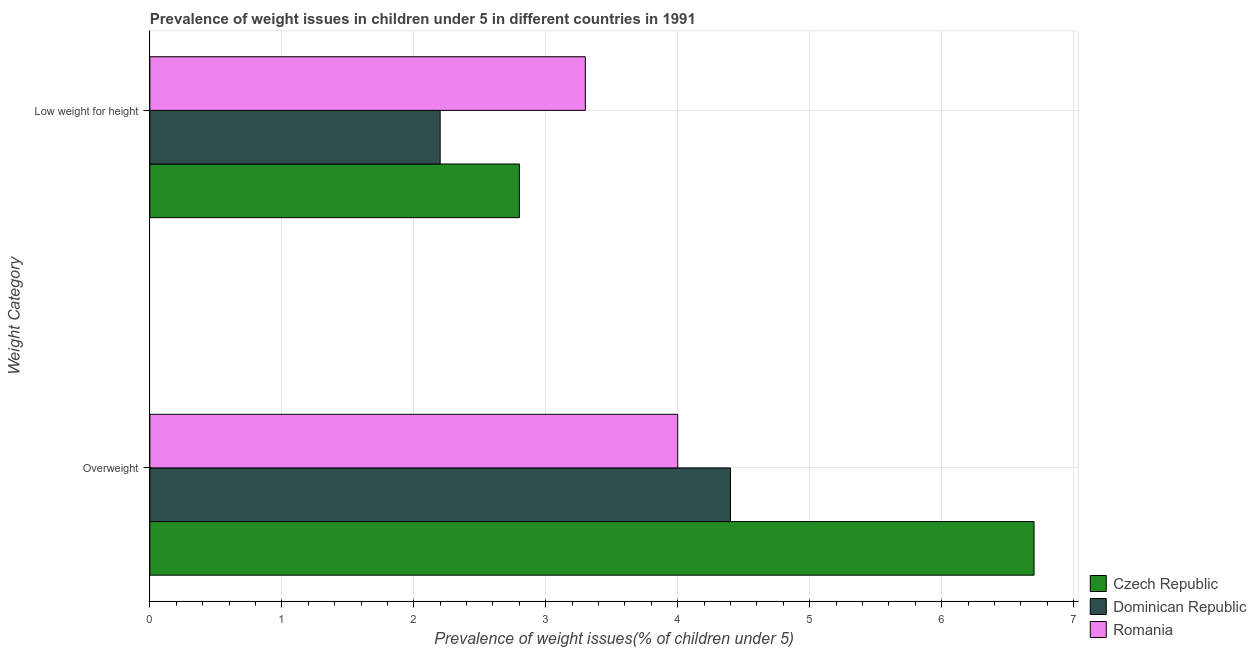How many different coloured bars are there?
Keep it short and to the point. 3. How many groups of bars are there?
Provide a succinct answer. 2. What is the label of the 1st group of bars from the top?
Make the answer very short. Low weight for height. What is the percentage of overweight children in Czech Republic?
Your response must be concise. 6.7. Across all countries, what is the maximum percentage of overweight children?
Offer a terse response. 6.7. Across all countries, what is the minimum percentage of overweight children?
Offer a terse response. 4. In which country was the percentage of underweight children maximum?
Your answer should be very brief. Romania. In which country was the percentage of underweight children minimum?
Your answer should be very brief. Dominican Republic. What is the total percentage of underweight children in the graph?
Offer a very short reply. 8.3. What is the difference between the percentage of overweight children in Czech Republic and that in Dominican Republic?
Make the answer very short. 2.3. What is the difference between the percentage of overweight children in Czech Republic and the percentage of underweight children in Romania?
Your response must be concise. 3.4. What is the average percentage of underweight children per country?
Provide a succinct answer. 2.77. What is the difference between the percentage of underweight children and percentage of overweight children in Dominican Republic?
Offer a terse response. -2.2. In how many countries, is the percentage of overweight children greater than 1.2 %?
Offer a terse response. 3. What is the ratio of the percentage of overweight children in Czech Republic to that in Romania?
Your response must be concise. 1.67. Is the percentage of overweight children in Dominican Republic less than that in Czech Republic?
Your answer should be compact. Yes. What does the 3rd bar from the top in Low weight for height represents?
Your answer should be very brief. Czech Republic. What does the 2nd bar from the bottom in Overweight represents?
Ensure brevity in your answer.  Dominican Republic. How many bars are there?
Keep it short and to the point. 6. What is the difference between two consecutive major ticks on the X-axis?
Make the answer very short. 1. Does the graph contain any zero values?
Provide a succinct answer. No. Does the graph contain grids?
Give a very brief answer. Yes. Where does the legend appear in the graph?
Provide a succinct answer. Bottom right. How many legend labels are there?
Your response must be concise. 3. What is the title of the graph?
Give a very brief answer. Prevalence of weight issues in children under 5 in different countries in 1991. Does "Small states" appear as one of the legend labels in the graph?
Your answer should be compact. No. What is the label or title of the X-axis?
Your response must be concise. Prevalence of weight issues(% of children under 5). What is the label or title of the Y-axis?
Give a very brief answer. Weight Category. What is the Prevalence of weight issues(% of children under 5) of Czech Republic in Overweight?
Your response must be concise. 6.7. What is the Prevalence of weight issues(% of children under 5) of Dominican Republic in Overweight?
Provide a succinct answer. 4.4. What is the Prevalence of weight issues(% of children under 5) in Romania in Overweight?
Offer a very short reply. 4. What is the Prevalence of weight issues(% of children under 5) in Czech Republic in Low weight for height?
Your response must be concise. 2.8. What is the Prevalence of weight issues(% of children under 5) in Dominican Republic in Low weight for height?
Make the answer very short. 2.2. What is the Prevalence of weight issues(% of children under 5) in Romania in Low weight for height?
Ensure brevity in your answer.  3.3. Across all Weight Category, what is the maximum Prevalence of weight issues(% of children under 5) of Czech Republic?
Your response must be concise. 6.7. Across all Weight Category, what is the maximum Prevalence of weight issues(% of children under 5) in Dominican Republic?
Offer a very short reply. 4.4. Across all Weight Category, what is the minimum Prevalence of weight issues(% of children under 5) in Czech Republic?
Provide a short and direct response. 2.8. Across all Weight Category, what is the minimum Prevalence of weight issues(% of children under 5) of Dominican Republic?
Keep it short and to the point. 2.2. Across all Weight Category, what is the minimum Prevalence of weight issues(% of children under 5) in Romania?
Provide a short and direct response. 3.3. What is the total Prevalence of weight issues(% of children under 5) of Czech Republic in the graph?
Make the answer very short. 9.5. What is the total Prevalence of weight issues(% of children under 5) in Dominican Republic in the graph?
Offer a very short reply. 6.6. What is the total Prevalence of weight issues(% of children under 5) in Romania in the graph?
Keep it short and to the point. 7.3. What is the difference between the Prevalence of weight issues(% of children under 5) in Dominican Republic in Overweight and that in Low weight for height?
Make the answer very short. 2.2. What is the difference between the Prevalence of weight issues(% of children under 5) in Czech Republic in Overweight and the Prevalence of weight issues(% of children under 5) in Romania in Low weight for height?
Your answer should be compact. 3.4. What is the average Prevalence of weight issues(% of children under 5) in Czech Republic per Weight Category?
Keep it short and to the point. 4.75. What is the average Prevalence of weight issues(% of children under 5) in Romania per Weight Category?
Your answer should be compact. 3.65. What is the difference between the Prevalence of weight issues(% of children under 5) in Czech Republic and Prevalence of weight issues(% of children under 5) in Dominican Republic in Overweight?
Ensure brevity in your answer.  2.3. What is the difference between the Prevalence of weight issues(% of children under 5) in Dominican Republic and Prevalence of weight issues(% of children under 5) in Romania in Low weight for height?
Your response must be concise. -1.1. What is the ratio of the Prevalence of weight issues(% of children under 5) of Czech Republic in Overweight to that in Low weight for height?
Ensure brevity in your answer.  2.39. What is the ratio of the Prevalence of weight issues(% of children under 5) of Dominican Republic in Overweight to that in Low weight for height?
Your answer should be compact. 2. What is the ratio of the Prevalence of weight issues(% of children under 5) in Romania in Overweight to that in Low weight for height?
Ensure brevity in your answer.  1.21. What is the difference between the highest and the second highest Prevalence of weight issues(% of children under 5) of Czech Republic?
Give a very brief answer. 3.9. What is the difference between the highest and the second highest Prevalence of weight issues(% of children under 5) in Dominican Republic?
Offer a terse response. 2.2. 